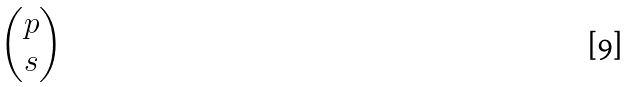Convert formula to latex. <formula><loc_0><loc_0><loc_500><loc_500>\begin{pmatrix} p \\ s \end{pmatrix}</formula> 